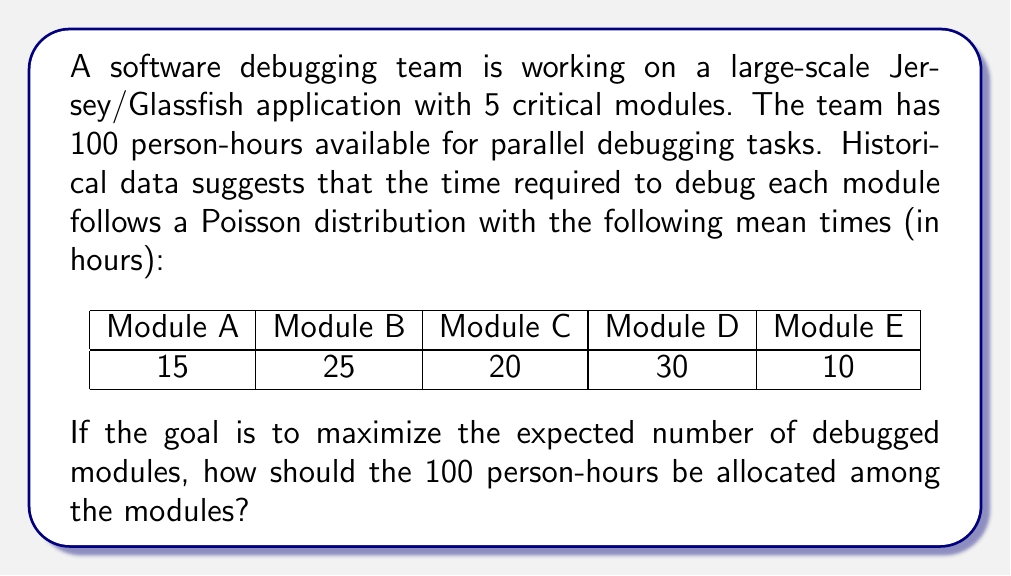What is the answer to this math problem? To solve this problem, we'll use the principles of decision theory and resource allocation. The key is to understand that we're dealing with a Poisson process for each module, where the probability of completing a module in a given time follows the cumulative distribution function of the Poisson distribution.

1. First, let's define our variables:
   $t_i$ = time allocated to module $i$
   $\lambda_i$ = mean time to debug module $i$

2. The probability of completing a module given an allocated time $t$ is:
   $P(\text{completion}) = 1 - e^{-t/\lambda}$

3. Our objective is to maximize the expected number of completed modules:
   $$\max E(\text{completed modules}) = \sum_{i=1}^5 (1 - e^{-t_i/\lambda_i})$$

4. Subject to the constraint:
   $$\sum_{i=1}^5 t_i = 100$$

5. This is a constrained optimization problem. We can solve it using the method of Lagrange multipliers. The Lagrangian is:
   $$L = \sum_{i=1}^5 (1 - e^{-t_i/\lambda_i}) - \mu(\sum_{i=1}^5 t_i - 100)$$

6. Taking partial derivatives and setting them to zero:
   $$\frac{\partial L}{\partial t_i} = \frac{1}{\lambda_i}e^{-t_i/\lambda_i} - \mu = 0$$
   $$\frac{\partial L}{\partial \mu} = \sum_{i=1}^5 t_i - 100 = 0$$

7. From the first equation:
   $$t_i = -\lambda_i \ln(\mu\lambda_i)$$

8. Substituting into the constraint equation:
   $$\sum_{i=1}^5 -\lambda_i \ln(\mu\lambda_i) = 100$$

9. This equation can be solved numerically for $\mu$, and then we can calculate $t_i$ for each module.

10. Solving numerically (using a computer algebra system or numerical methods), we get:
    $\mu \approx 0.0296$

11. Substituting back, we get the optimal time allocations:
    $t_A \approx 17.8$ hours
    $t_B \approx 27.8$ hours
    $t_C \approx 22.8$ hours
    $t_D \approx 32.8$ hours
    $t_E \approx 12.8$ hours

These allocations maximize the expected number of completed modules given the constraints.
Answer: The optimal allocation of the 100 person-hours for parallel debugging tasks is approximately:
Module A: 17.8 hours
Module B: 27.8 hours
Module C: 22.8 hours
Module D: 32.8 hours
Module E: 12.8 hours 